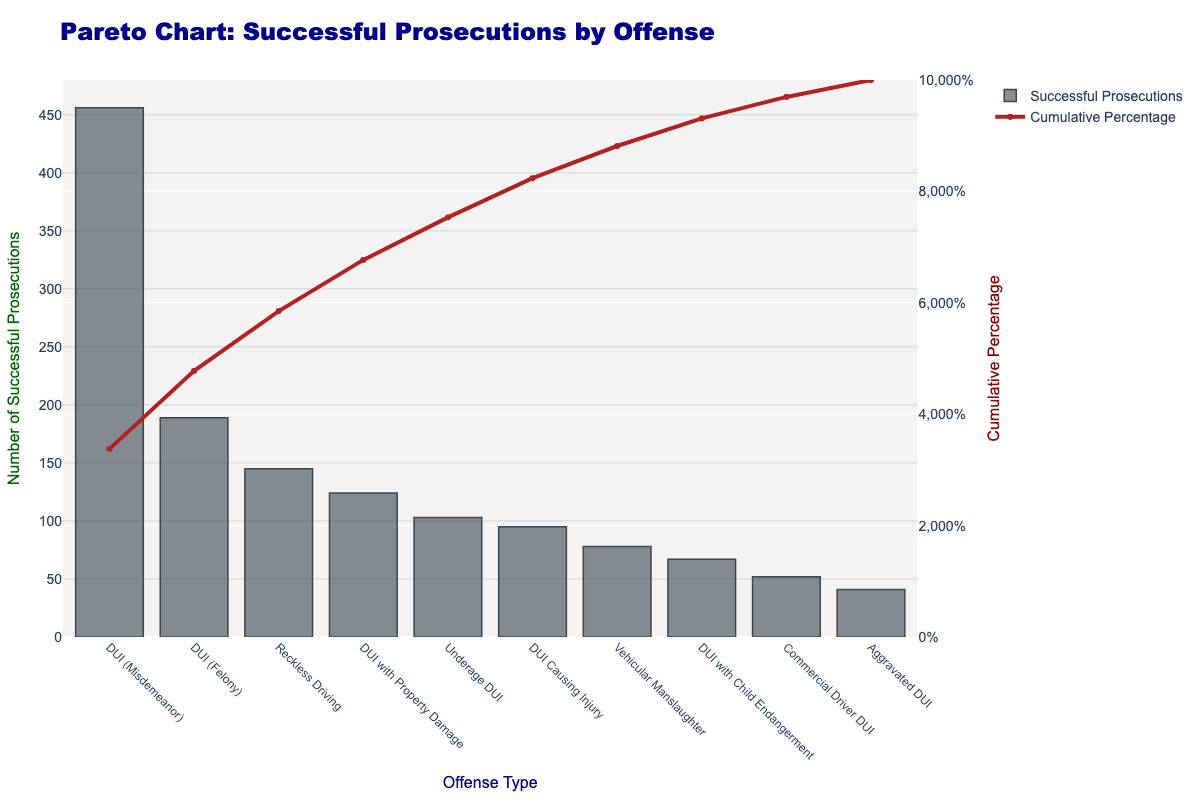What's the title of the figure? The title is shown at the top center of the chart. It reads "Pareto Chart: Successful Prosecutions by Offense" in a bold, dark blue font.
Answer: Pareto Chart: Successful Prosecutions by Offense What does the y-axis on the left represent? The y-axis on the left, labeled "Number of Successful Prosecutions," represents the count of successful prosecutions for each offense type.
Answer: Number of Successful Prosecutions Which offense has the most successful prosecutions? By examining the bar heights, the tallest bar corresponds to "DUI (Misdemeanor)" with 456 successful prosecutions.
Answer: DUI (Misdemeanor) What is the cumulative percentage for "DUI with Property Damage"? Locate the offense on the x-axis and follow the corresponding line plot up. The line reaches about the cumulative percentage value.
Answer: Approximately 85% How many offenses exceed 100 successful prosecutions? Count the bars that pass the 100-mark on the y-axis. The offenses are "DUI (Misdemeanor)", "DUI (Felony)", "Reckless Driving", "Underage DUI", "DUI Causing Injury", and "DUI with Property Damage".
Answer: Six Which offenses contribute to more than 50% of the cumulative successful prosecutions? Observe the cumulative percentage line and identify offenses until it exceeds 50%. The offenses are "DUI (Misdemeanor)", "DUI (Felony)", and "Reckless Driving".
Answer: Three offenses What is the difference in successful prosecutions between "DUI with Child Endangerment" and "Commercial Driver DUI"? Subtract the successful prosecutions of "Commercial Driver DUI" (52) from "DUI with Child Endangerment" (67).
Answer: 15 Is the cumulative percentage line ever decreasing? In a Pareto chart, the cumulative percentage line always either stays the same or increases as you progress along the x-axis.
Answer: No Which offense has the smallest number of successful prosecutions? Identify the shortest bar; it corresponds to "Aggravated DUI" with 41 successful prosecutions.
Answer: Aggravated DUI 